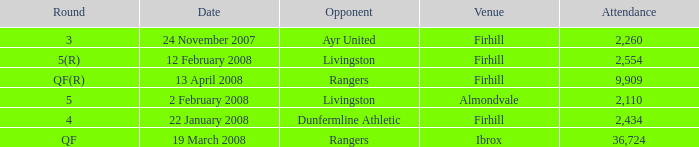What is the average attendance at a game held at Firhill for the 5(r) round? 2554.0. Could you help me parse every detail presented in this table? {'header': ['Round', 'Date', 'Opponent', 'Venue', 'Attendance'], 'rows': [['3', '24 November 2007', 'Ayr United', 'Firhill', '2,260'], ['5(R)', '12 February 2008', 'Livingston', 'Firhill', '2,554'], ['QF(R)', '13 April 2008', 'Rangers', 'Firhill', '9,909'], ['5', '2 February 2008', 'Livingston', 'Almondvale', '2,110'], ['4', '22 January 2008', 'Dunfermline Athletic', 'Firhill', '2,434'], ['QF', '19 March 2008', 'Rangers', 'Ibrox', '36,724']]} 